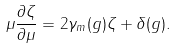<formula> <loc_0><loc_0><loc_500><loc_500>\mu \frac { \partial \zeta } { \partial \mu } = 2 \gamma _ { m } ( g ) \zeta + \delta ( g ) .</formula> 